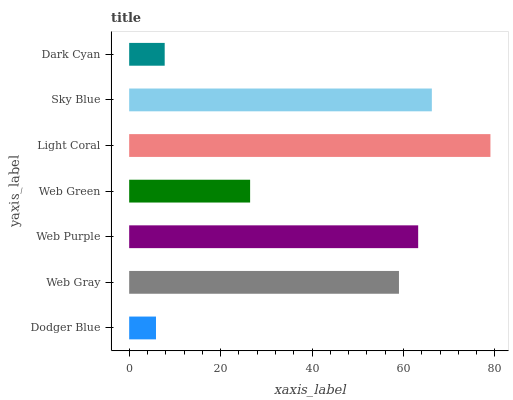Is Dodger Blue the minimum?
Answer yes or no. Yes. Is Light Coral the maximum?
Answer yes or no. Yes. Is Web Gray the minimum?
Answer yes or no. No. Is Web Gray the maximum?
Answer yes or no. No. Is Web Gray greater than Dodger Blue?
Answer yes or no. Yes. Is Dodger Blue less than Web Gray?
Answer yes or no. Yes. Is Dodger Blue greater than Web Gray?
Answer yes or no. No. Is Web Gray less than Dodger Blue?
Answer yes or no. No. Is Web Gray the high median?
Answer yes or no. Yes. Is Web Gray the low median?
Answer yes or no. Yes. Is Dodger Blue the high median?
Answer yes or no. No. Is Light Coral the low median?
Answer yes or no. No. 